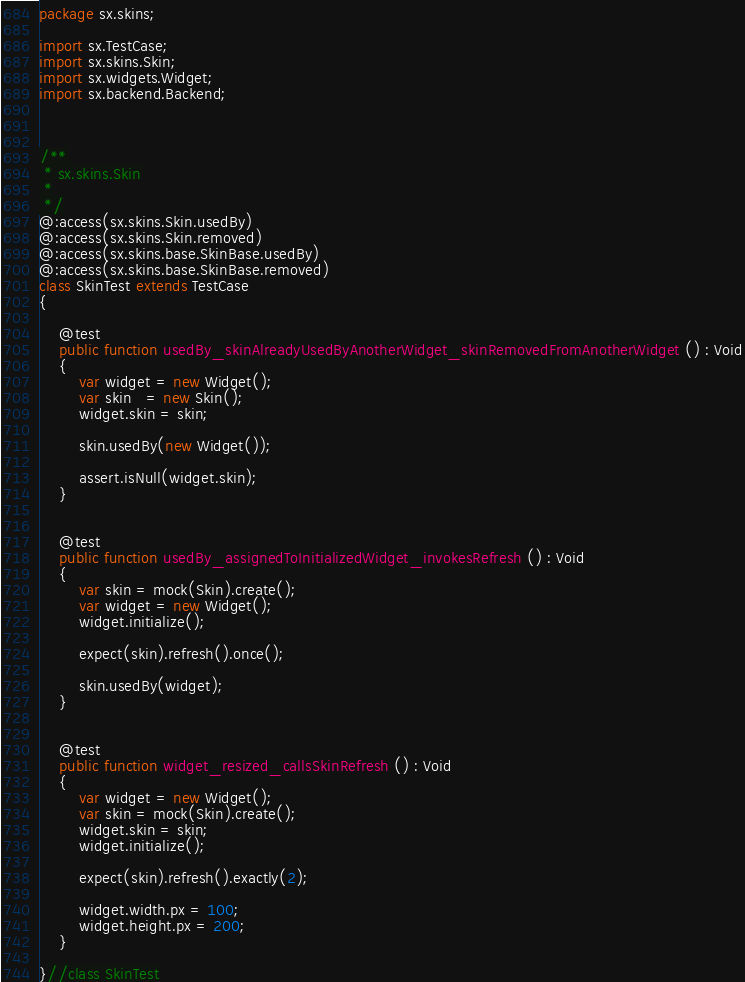<code> <loc_0><loc_0><loc_500><loc_500><_Haxe_>package sx.skins;

import sx.TestCase;
import sx.skins.Skin;
import sx.widgets.Widget;
import sx.backend.Backend;



/**
 * sx.skins.Skin
 *
 */
@:access(sx.skins.Skin.usedBy)
@:access(sx.skins.Skin.removed)
@:access(sx.skins.base.SkinBase.usedBy)
@:access(sx.skins.base.SkinBase.removed)
class SkinTest extends TestCase
{

    @test
    public function usedBy_skinAlreadyUsedByAnotherWidget_skinRemovedFromAnotherWidget () : Void
    {
        var widget = new Widget();
        var skin   = new Skin();
        widget.skin = skin;

        skin.usedBy(new Widget());

        assert.isNull(widget.skin);
    }


    @test
    public function usedBy_assignedToInitializedWidget_invokesRefresh () : Void
    {
        var skin = mock(Skin).create();
        var widget = new Widget();
        widget.initialize();

        expect(skin).refresh().once();

        skin.usedBy(widget);
    }


    @test
    public function widget_resized_callsSkinRefresh () : Void
    {
        var widget = new Widget();
        var skin = mock(Skin).create();
        widget.skin = skin;
        widget.initialize();

        expect(skin).refresh().exactly(2);

        widget.width.px = 100;
        widget.height.px = 200;
    }

}//class SkinTest</code> 